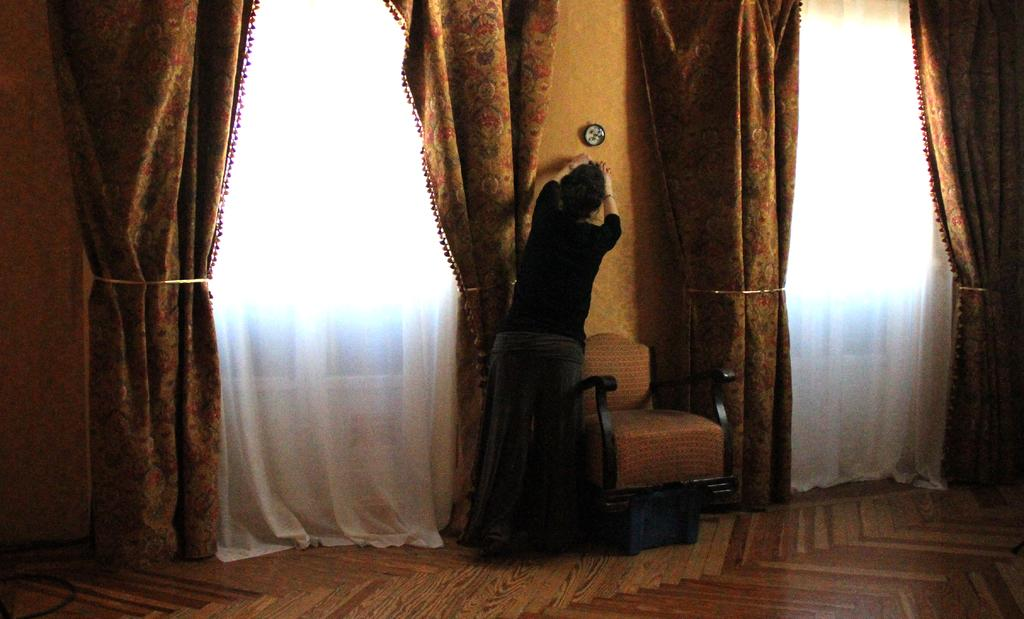What is the main subject of the image? There is a person standing in the image. Where is the person standing? The person is standing on the floor. What other objects can be seen in the image? There is a chair in the image. What can be seen in the background of the image? There is a wall and curtains in the background of the image. What type of railway can be seen in the image? There is no railway present in the image. How many cars are visible in the image? There are no cars visible in the image. 